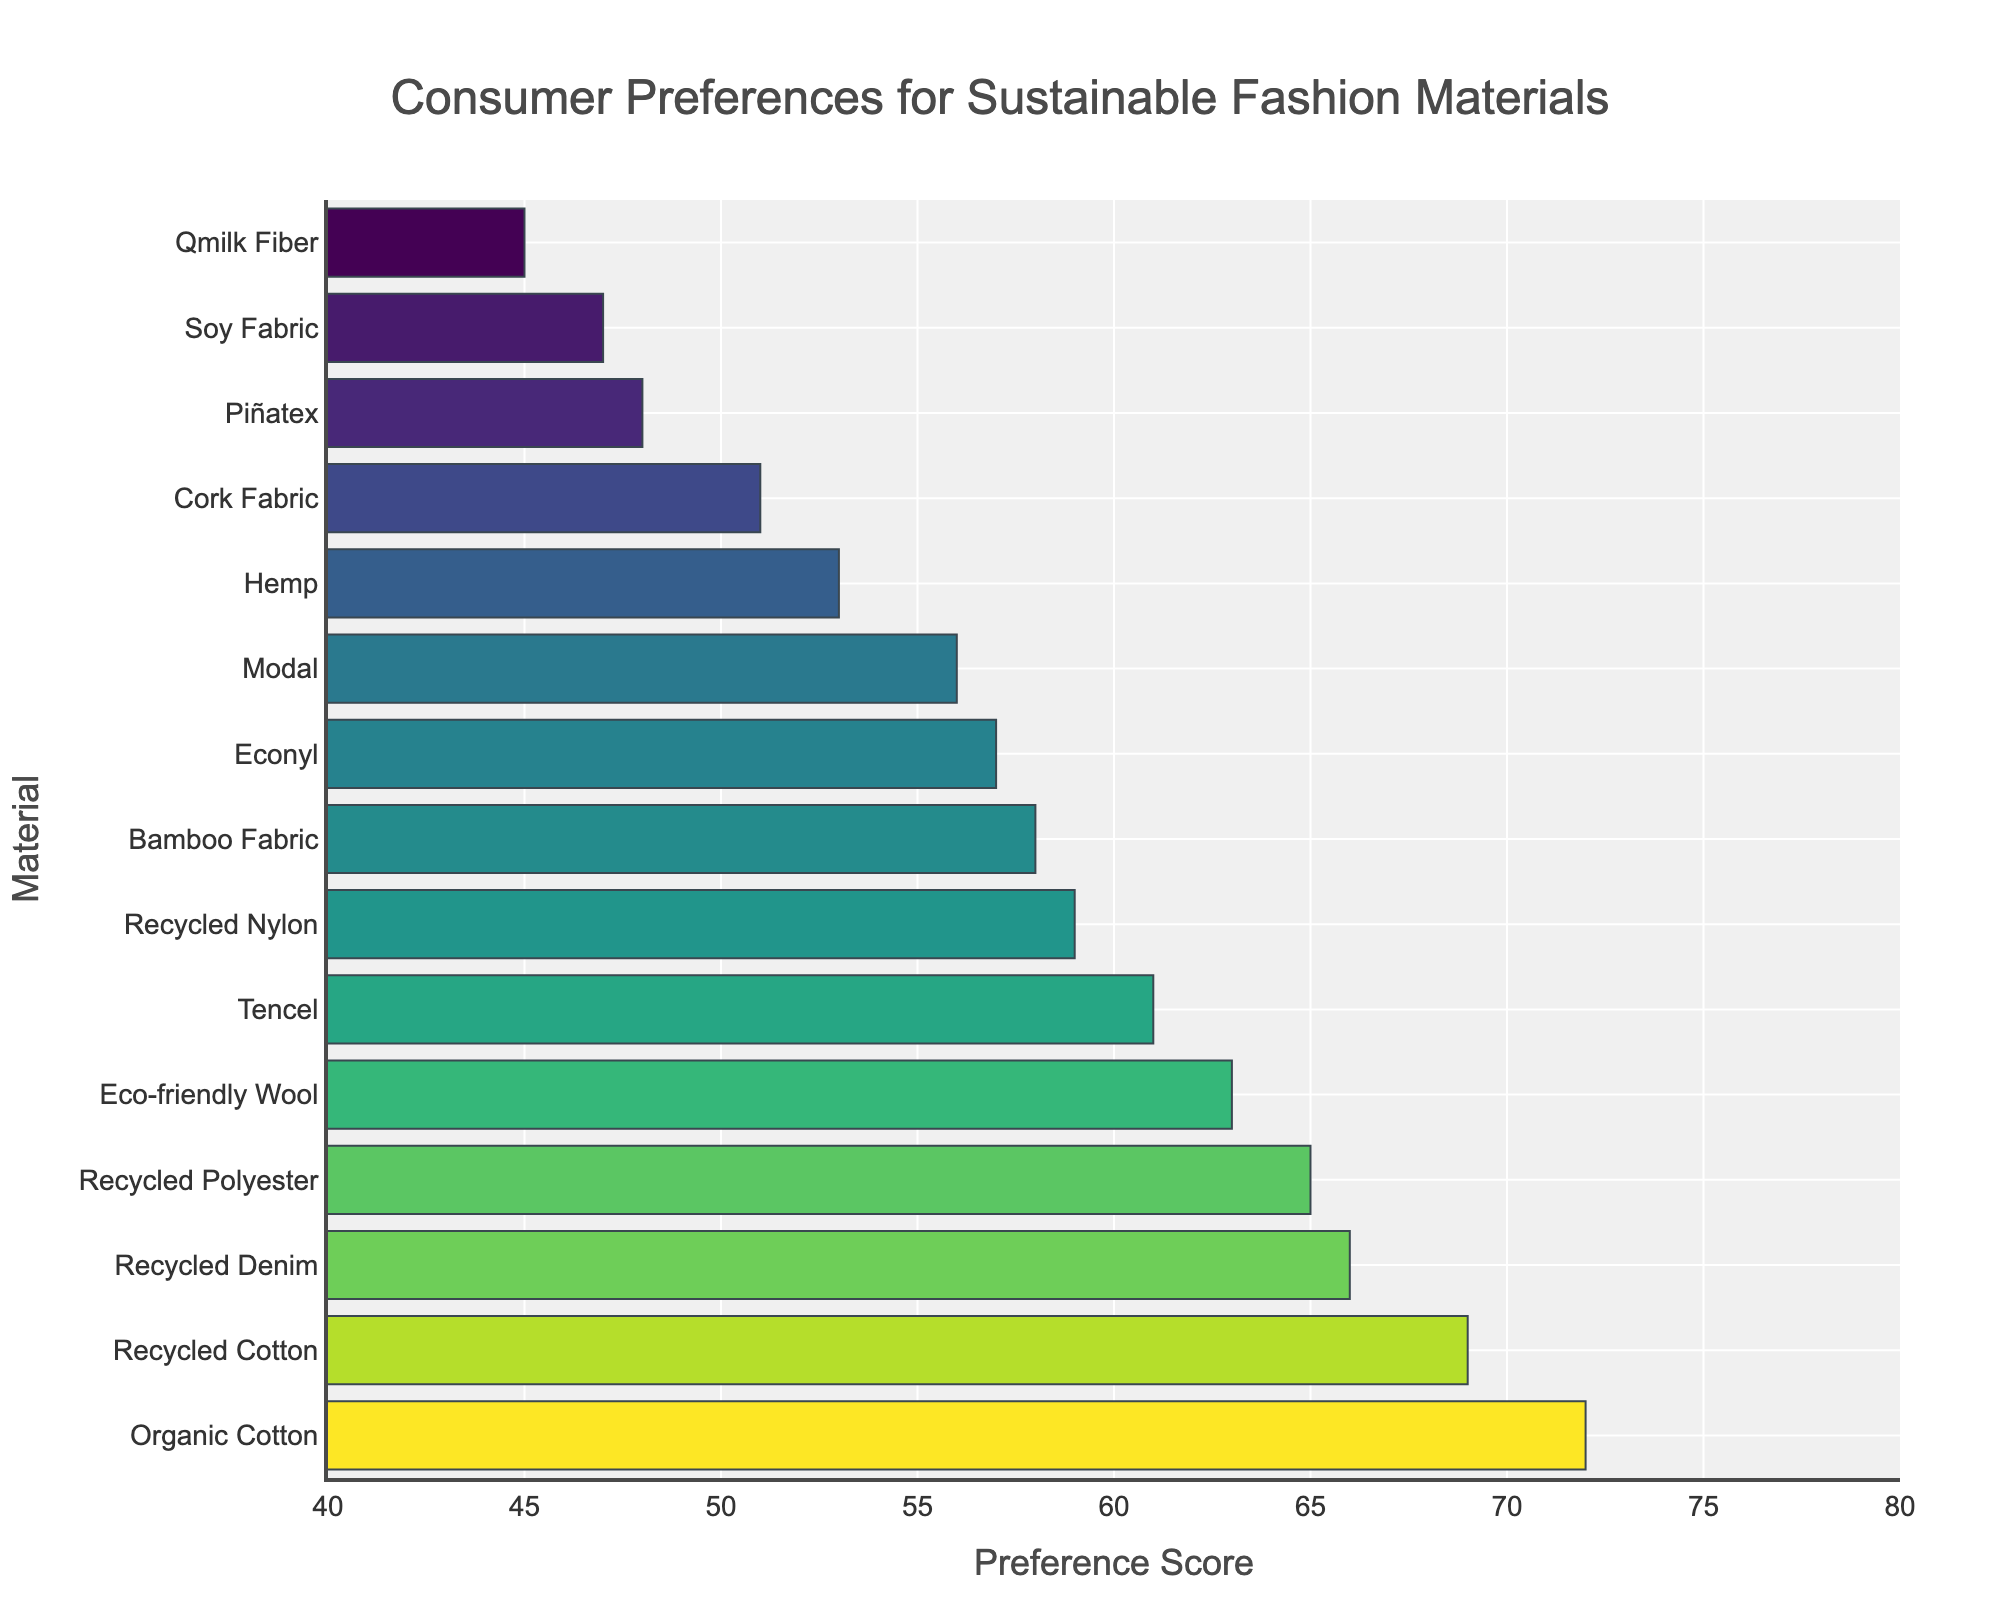What is the most preferred fashion material in terms of sustainability? The chart shows the preference scores of various materials in descending order. The material with the highest score is Organic Cotton.
Answer: Organic Cotton What is the difference in preference score between Recycled Cotton and Recycled Denim? From the chart, the score for Recycled Cotton is 69 and for Recycled Denim is 66. Therefore, the difference is 69 - 66 = 3.
Answer: 3 Which material has a higher preference score, Bamboo Fabric or Econyl? By comparing the bars, Bamboo Fabric has a preference score of 58, while Econyl has a score of 57. Bamboo Fabric has a higher score.
Answer: Bamboo Fabric What is the average preference score of the top three sustainable fashion materials? The top three materials are Organic Cotton (72), Recycled Cotton (69), and Recycled Denim (66). Their average score is (72 + 69 + 66) / 3 = 69.
Answer: 69 How many fashion materials have a preference score greater than 60? The chart shows materials and their scores. The materials with scores greater than 60 are Organic Cotton, Recycled Cotton, Recycled Denim, Eco-friendly Wool, and Tencel. There are 5 such materials.
Answer: 5 Is the preference score of Hemp higher or lower than Cork Fabric? From the chart, Hemp has a score of 53, while Cork Fabric has a score of 51. Thus, Hemp has a higher score.
Answer: Higher What is the sum of preference scores for Tencel, Eco-friendly Wool, and Modal? The chart shows their respective scores: Tencel (61), Eco-friendly Wool (63), and Modal (56). The sum is 61 + 63 + 56 = 180.
Answer: 180 Which material has the lowest preference score, and what is it? The material with the shortest bar is Qmilk Fiber, with a score of 45.
Answer: Qmilk Fiber, 45 What is the median preference score for all the materials listed? To find the median, sort all preference scores: 45, 47, 48, 51, 53, 56, 57, 58, 59, 61, 63, 65, 66, 69, 72. The middle value (8th score) is 58.
Answer: 58 What is the difference in preference scores between the most and least preferred materials? The highest score is for Organic Cotton (72) and the lowest is for Qmilk Fiber (45). The difference is 72 - 45 = 27.
Answer: 27 